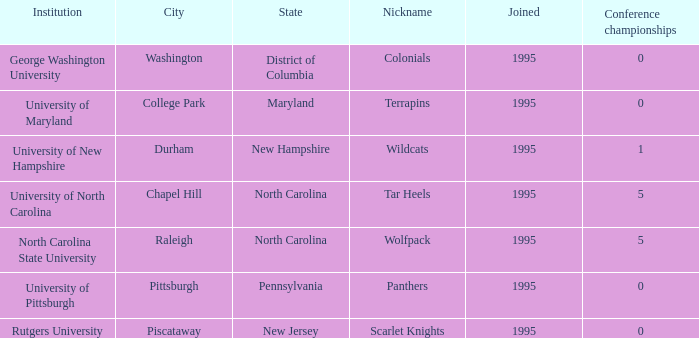What is the lowest year joined in the city of College Park at the Conference championships smaller than 0? None. 